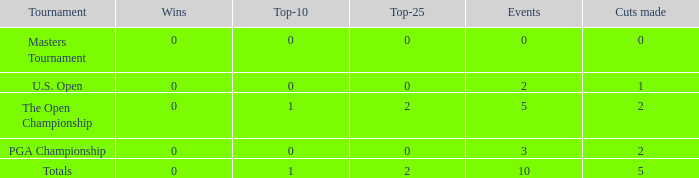In events with zero wins, what is the cumulative number of top-25 standings? 0.0. 